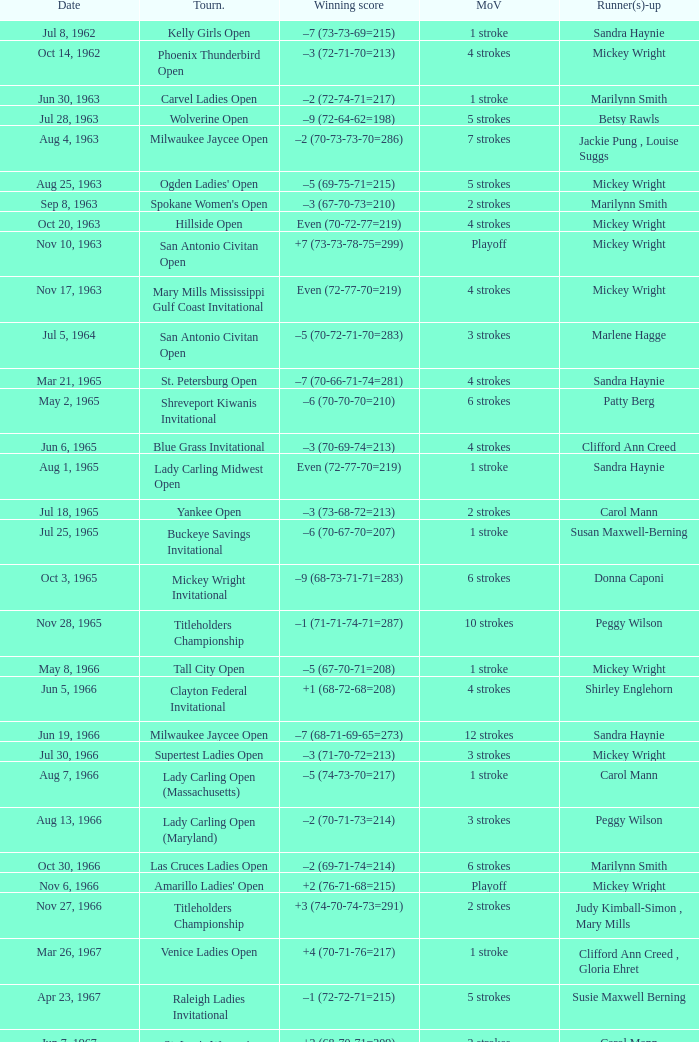What was the winning score when there were 9 strokes advantage? –7 (73-68-73-67=281). 